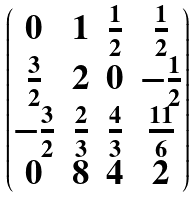<formula> <loc_0><loc_0><loc_500><loc_500>\begin{pmatrix} 0 & 1 & \frac { 1 } { 2 } & \frac { 1 } { 2 } \\ \frac { 3 } { 2 } & 2 & 0 & - \frac { 1 } { 2 } \\ - \frac { 3 } { 2 } & \frac { 2 } { 3 } & \frac { 4 } { 3 } & \frac { 1 1 } { 6 } \\ 0 & 8 & 4 & 2 \end{pmatrix}</formula> 